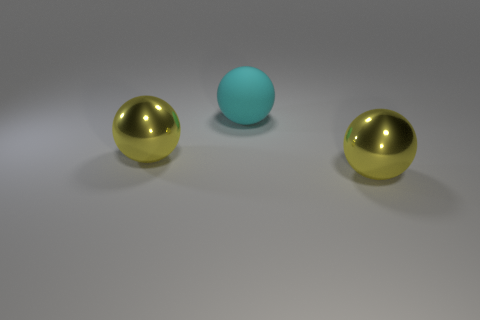Subtract all yellow shiny balls. How many balls are left? 1 Add 2 big brown things. How many objects exist? 5 Subtract all green cylinders. How many yellow balls are left? 2 Subtract all cyan balls. How many balls are left? 2 Subtract all yellow balls. Subtract all red cylinders. How many balls are left? 1 Subtract all big cyan balls. Subtract all big cyan matte spheres. How many objects are left? 1 Add 2 spheres. How many spheres are left? 5 Add 1 big cyan objects. How many big cyan objects exist? 2 Subtract 0 gray cylinders. How many objects are left? 3 